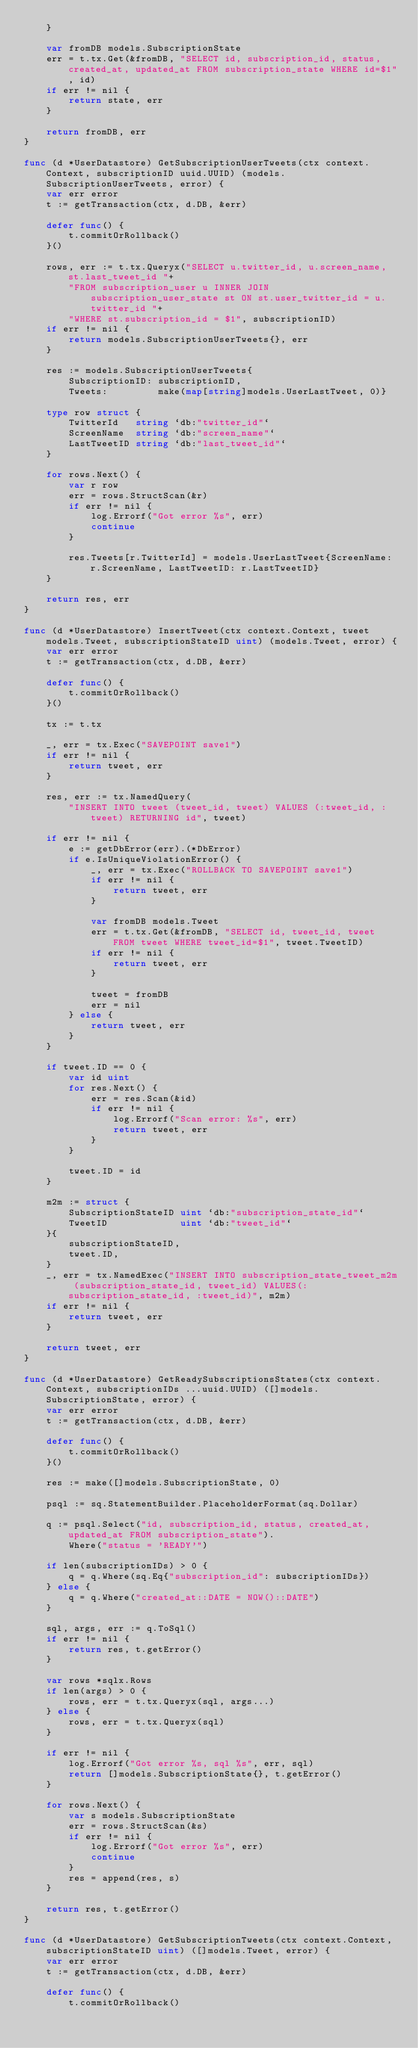Convert code to text. <code><loc_0><loc_0><loc_500><loc_500><_Go_>	}

	var fromDB models.SubscriptionState
	err = t.tx.Get(&fromDB, "SELECT id, subscription_id, status, created_at, updated_at FROM subscription_state WHERE id=$1", id)
	if err != nil {
		return state, err
	}

	return fromDB, err
}

func (d *UserDatastore) GetSubscriptionUserTweets(ctx context.Context, subscriptionID uuid.UUID) (models.SubscriptionUserTweets, error) {
	var err error
	t := getTransaction(ctx, d.DB, &err)

	defer func() {
		t.commitOrRollback()
	}()

	rows, err := t.tx.Queryx("SELECT u.twitter_id, u.screen_name, st.last_tweet_id "+
		"FROM subscription_user u INNER JOIN subscription_user_state st ON st.user_twitter_id = u.twitter_id "+
		"WHERE st.subscription_id = $1", subscriptionID)
	if err != nil {
		return models.SubscriptionUserTweets{}, err
	}

	res := models.SubscriptionUserTweets{
		SubscriptionID: subscriptionID,
		Tweets:         make(map[string]models.UserLastTweet, 0)}

	type row struct {
		TwitterId   string `db:"twitter_id"`
		ScreenName  string `db:"screen_name"`
		LastTweetID string `db:"last_tweet_id"`
	}

	for rows.Next() {
		var r row
		err = rows.StructScan(&r)
		if err != nil {
			log.Errorf("Got error %s", err)
			continue
		}

		res.Tweets[r.TwitterId] = models.UserLastTweet{ScreenName: r.ScreenName, LastTweetID: r.LastTweetID}
	}

	return res, err
}

func (d *UserDatastore) InsertTweet(ctx context.Context, tweet models.Tweet, subscriptionStateID uint) (models.Tweet, error) {
	var err error
	t := getTransaction(ctx, d.DB, &err)

	defer func() {
		t.commitOrRollback()
	}()

	tx := t.tx

	_, err = tx.Exec("SAVEPOINT save1")
	if err != nil {
		return tweet, err
	}

	res, err := tx.NamedQuery(
		"INSERT INTO tweet (tweet_id, tweet) VALUES (:tweet_id, :tweet) RETURNING id", tweet)

	if err != nil {
		e := getDbError(err).(*DbError)
		if e.IsUniqueViolationError() {
			_, err = tx.Exec("ROLLBACK TO SAVEPOINT save1")
			if err != nil {
				return tweet, err
			}

			var fromDB models.Tweet
			err = t.tx.Get(&fromDB, "SELECT id, tweet_id, tweet FROM tweet WHERE tweet_id=$1", tweet.TweetID)
			if err != nil {
				return tweet, err
			}

			tweet = fromDB
			err = nil
		} else {
			return tweet, err
		}
	}

	if tweet.ID == 0 {
		var id uint
		for res.Next() {
			err = res.Scan(&id)
			if err != nil {
				log.Errorf("Scan error: %s", err)
				return tweet, err
			}
		}

		tweet.ID = id
	}

	m2m := struct {
		SubscriptionStateID uint `db:"subscription_state_id"`
		TweetID             uint `db:"tweet_id"`
	}{
		subscriptionStateID,
		tweet.ID,
	}
	_, err = tx.NamedExec("INSERT INTO subscription_state_tweet_m2m (subscription_state_id, tweet_id) VALUES(:subscription_state_id, :tweet_id)", m2m)
	if err != nil {
		return tweet, err
	}

	return tweet, err
}

func (d *UserDatastore) GetReadySubscriptionsStates(ctx context.Context, subscriptionIDs ...uuid.UUID) ([]models.SubscriptionState, error) {
	var err error
	t := getTransaction(ctx, d.DB, &err)

	defer func() {
		t.commitOrRollback()
	}()

	res := make([]models.SubscriptionState, 0)

	psql := sq.StatementBuilder.PlaceholderFormat(sq.Dollar)

	q := psql.Select("id, subscription_id, status, created_at, updated_at FROM subscription_state").
		Where("status = 'READY'")

	if len(subscriptionIDs) > 0 {
		q = q.Where(sq.Eq{"subscription_id": subscriptionIDs})
	} else {
		q = q.Where("created_at::DATE = NOW()::DATE")
	}

	sql, args, err := q.ToSql()
	if err != nil {
		return res, t.getError()
	}

	var rows *sqlx.Rows
	if len(args) > 0 {
		rows, err = t.tx.Queryx(sql, args...)
	} else {
		rows, err = t.tx.Queryx(sql)
	}

	if err != nil {
		log.Errorf("Got error %s, sql %s", err, sql)
		return []models.SubscriptionState{}, t.getError()
	}

	for rows.Next() {
		var s models.SubscriptionState
		err = rows.StructScan(&s)
		if err != nil {
			log.Errorf("Got error %s", err)
			continue
		}
		res = append(res, s)
	}

	return res, t.getError()
}

func (d *UserDatastore) GetSubscriptionTweets(ctx context.Context, subscriptionStateID uint) ([]models.Tweet, error) {
	var err error
	t := getTransaction(ctx, d.DB, &err)

	defer func() {
		t.commitOrRollback()</code> 